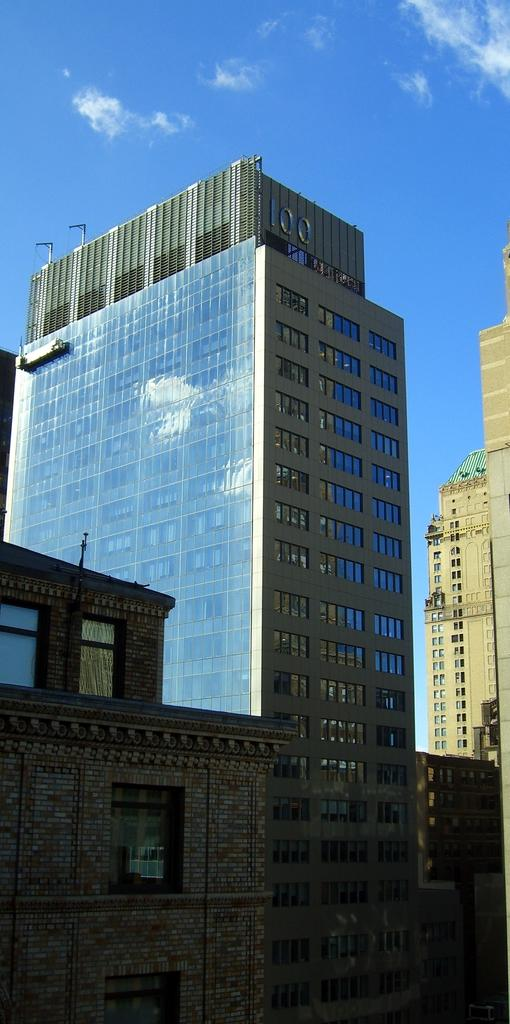What type of structures can be seen in the image? There are buildings in the image. What is visible at the top of the image? The sky is visible at the top of the image. Where are the cherries placed in the image? There are no cherries present in the image. What type of container is holding the quiver in the image? There is no quiver or container holding a quiver in the image. 